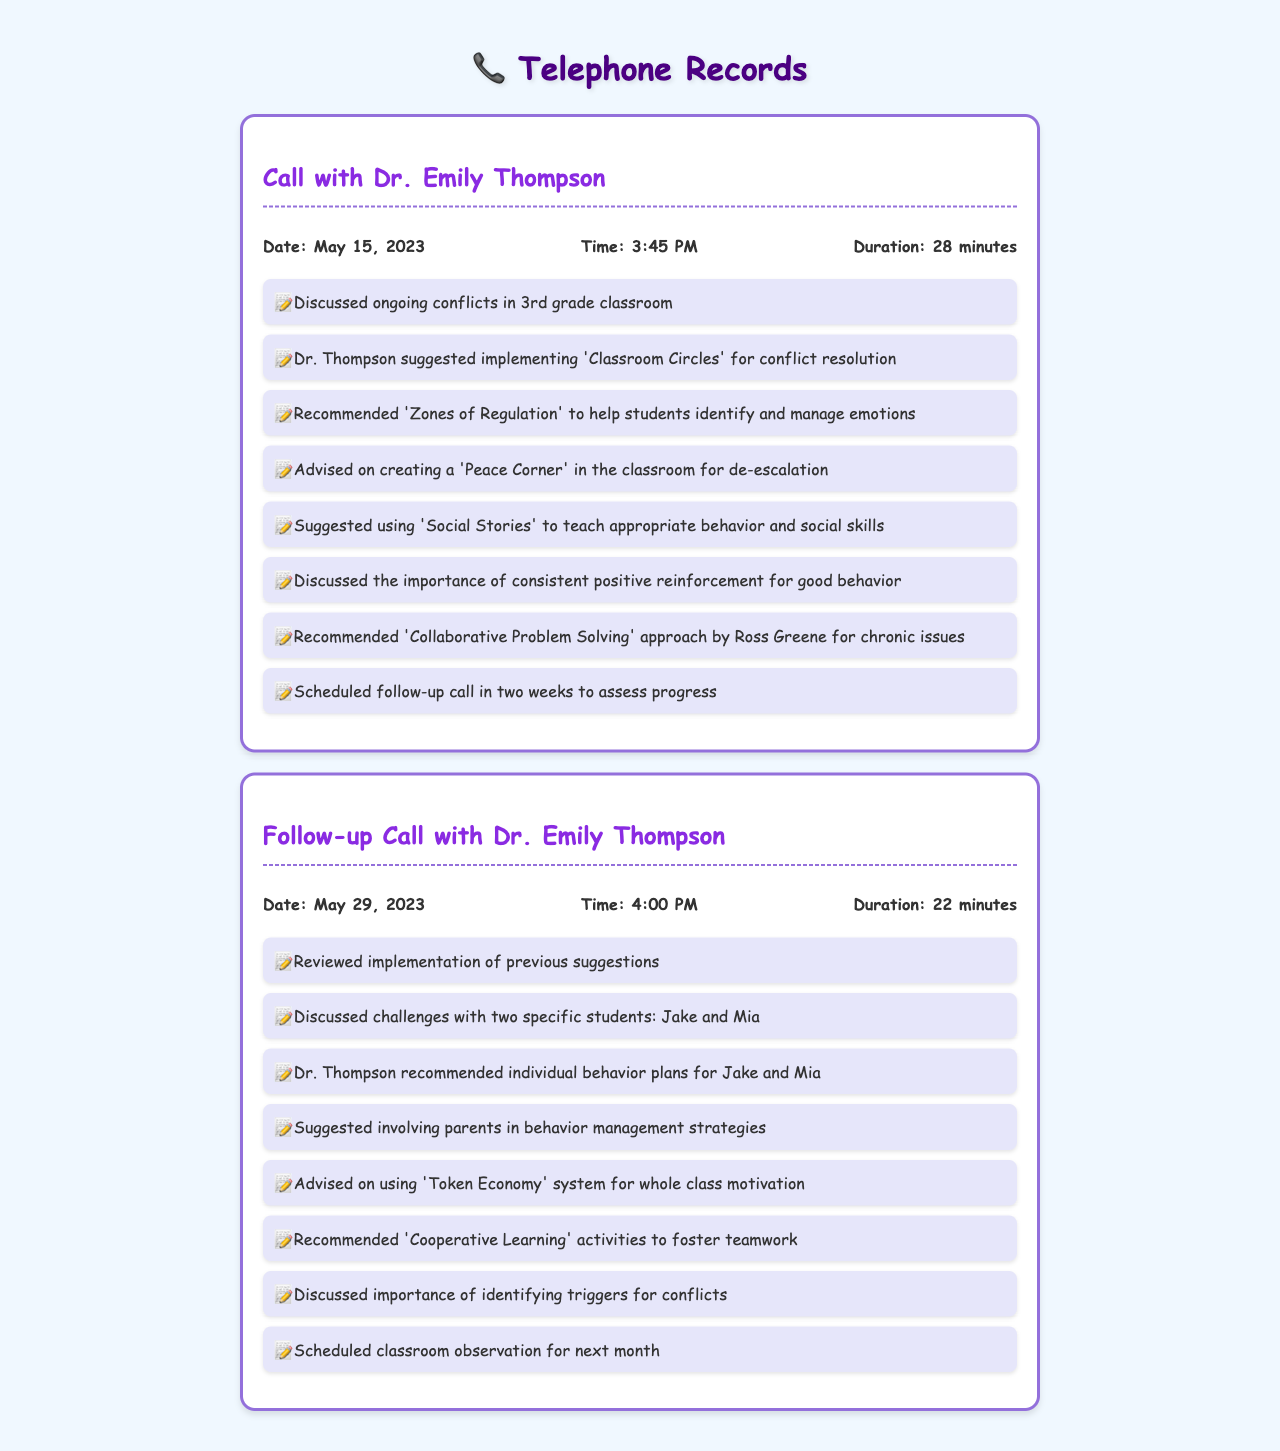What is the name of the psychologist? The psychologist's name mentioned in the document is Dr. Emily Thompson.
Answer: Dr. Emily Thompson What was the duration of the first call? The duration of the first call with Dr. Thompson was 28 minutes.
Answer: 28 minutes On what date was the follow-up call made? The follow-up call took place on May 29, 2023.
Answer: May 29, 2023 What intervention technique was suggested to help students manage emotions? The technique recommended for students to manage emotions is 'Zones of Regulation'.
Answer: Zones of Regulation Which two students were specifically discussed in the follow-up call? The two students discussed in the follow-up call are Jake and Mia.
Answer: Jake and Mia What is one suggested strategy for conflict resolution in the classroom? One strategy suggested for conflict resolution is 'Classroom Circles'.
Answer: Classroom Circles What was scheduled for the next month after the follow-up call? A classroom observation was scheduled for the next month.
Answer: classroom observation What approach did Dr. Thompson recommend for chronic issues? The recommended approach for chronic issues is 'Collaborative Problem Solving'.
Answer: Collaborative Problem Solving 